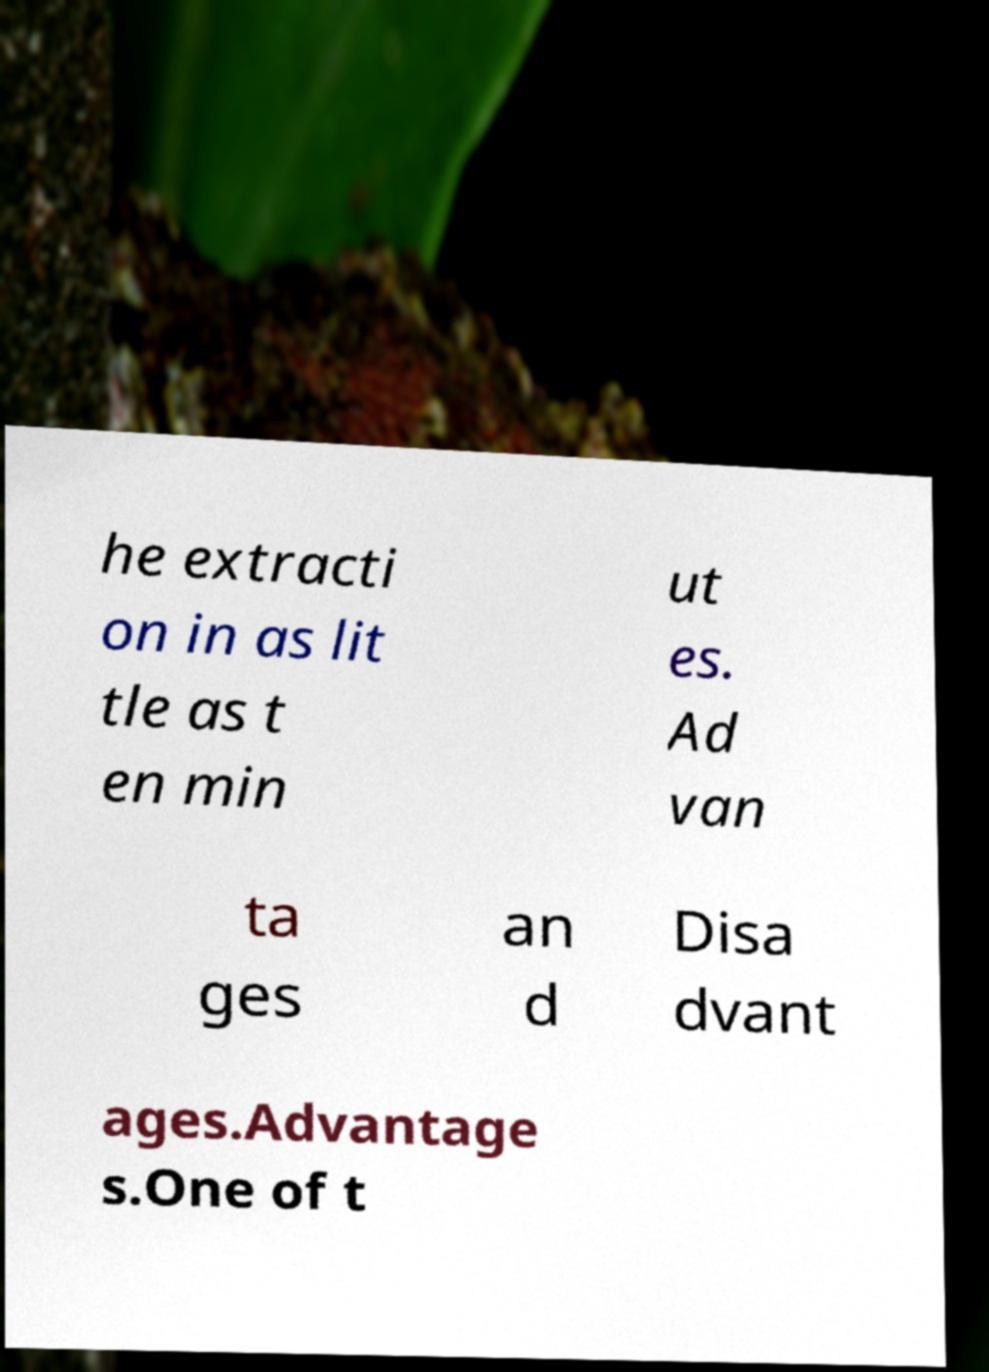Please identify and transcribe the text found in this image. he extracti on in as lit tle as t en min ut es. Ad van ta ges an d Disa dvant ages.Advantage s.One of t 